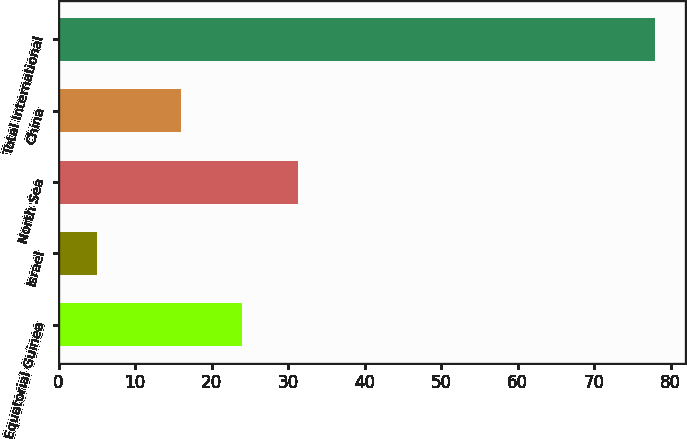Convert chart. <chart><loc_0><loc_0><loc_500><loc_500><bar_chart><fcel>Equatorial Guinea<fcel>Israel<fcel>North Sea<fcel>China<fcel>Total International<nl><fcel>24<fcel>5<fcel>31.3<fcel>16<fcel>78<nl></chart> 